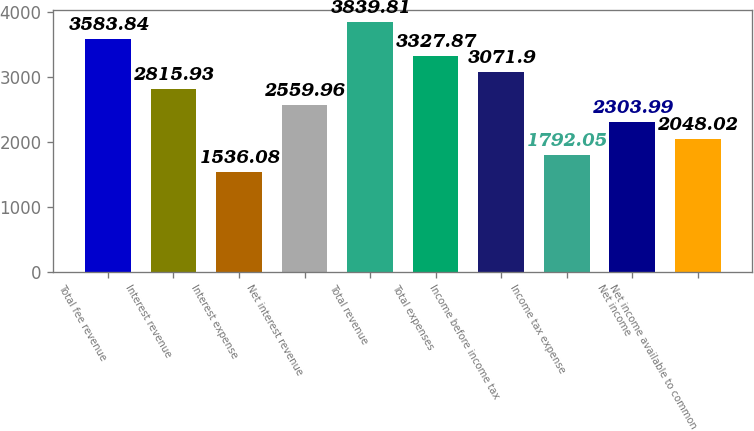<chart> <loc_0><loc_0><loc_500><loc_500><bar_chart><fcel>Total fee revenue<fcel>Interest revenue<fcel>Interest expense<fcel>Net interest revenue<fcel>Total revenue<fcel>Total expenses<fcel>Income before income tax<fcel>Income tax expense<fcel>Net income<fcel>Net income available to common<nl><fcel>3583.84<fcel>2815.93<fcel>1536.08<fcel>2559.96<fcel>3839.81<fcel>3327.87<fcel>3071.9<fcel>1792.05<fcel>2303.99<fcel>2048.02<nl></chart> 